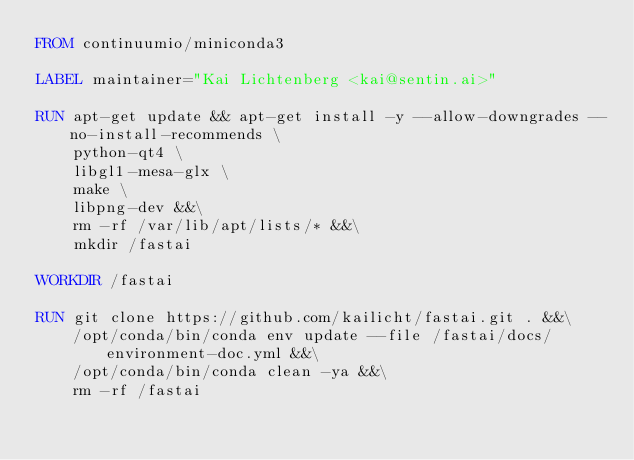Convert code to text. <code><loc_0><loc_0><loc_500><loc_500><_Dockerfile_>FROM continuumio/miniconda3

LABEL maintainer="Kai Lichtenberg <kai@sentin.ai>"

RUN apt-get update && apt-get install -y --allow-downgrades --no-install-recommends \
    python-qt4 \
    libgl1-mesa-glx \
    make \
    libpng-dev &&\
    rm -rf /var/lib/apt/lists/* &&\
    mkdir /fastai

WORKDIR /fastai

RUN git clone https://github.com/kailicht/fastai.git . &&\
    /opt/conda/bin/conda env update --file /fastai/docs/environment-doc.yml &&\
    /opt/conda/bin/conda clean -ya &&\
    rm -rf /fastai
</code> 